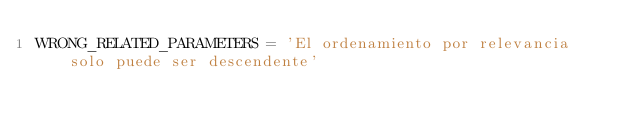Convert code to text. <code><loc_0><loc_0><loc_500><loc_500><_Python_>WRONG_RELATED_PARAMETERS = 'El ordenamiento por relevancia solo puede ser descendente'
</code> 